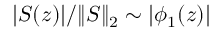<formula> <loc_0><loc_0><loc_500><loc_500>| S ( z ) | / \| S \| _ { 2 } \sim | \phi _ { 1 } ( z ) |</formula> 